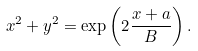Convert formula to latex. <formula><loc_0><loc_0><loc_500><loc_500>x ^ { 2 } + y ^ { 2 } = \exp \left ( 2 \frac { x + a } B \right ) .</formula> 